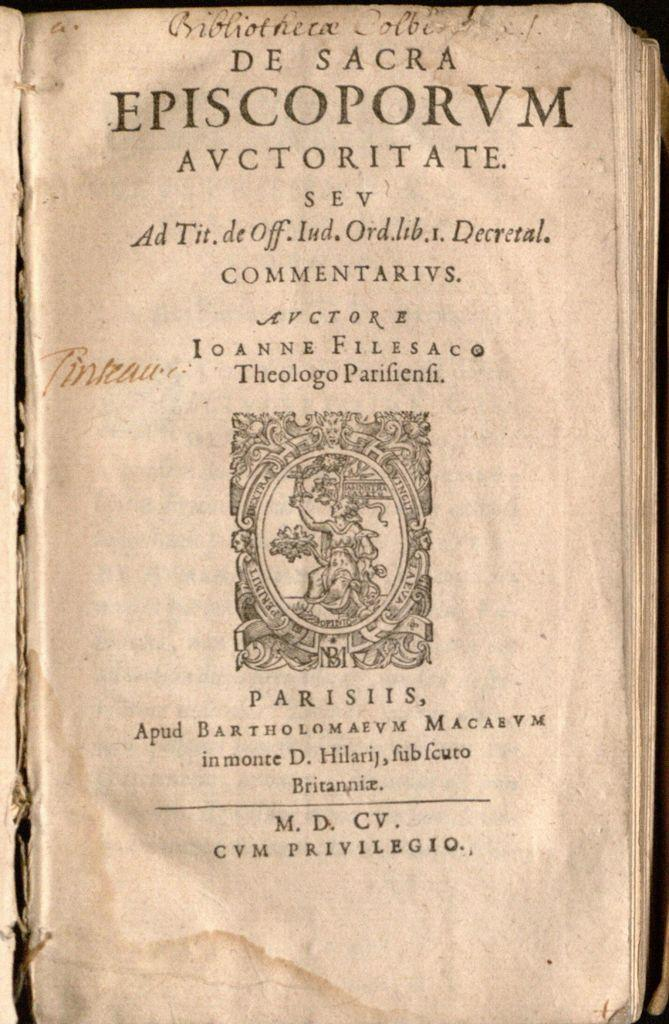<image>
Present a compact description of the photo's key features. A cover page for an old book with the text episcoporum in bold at the top. 